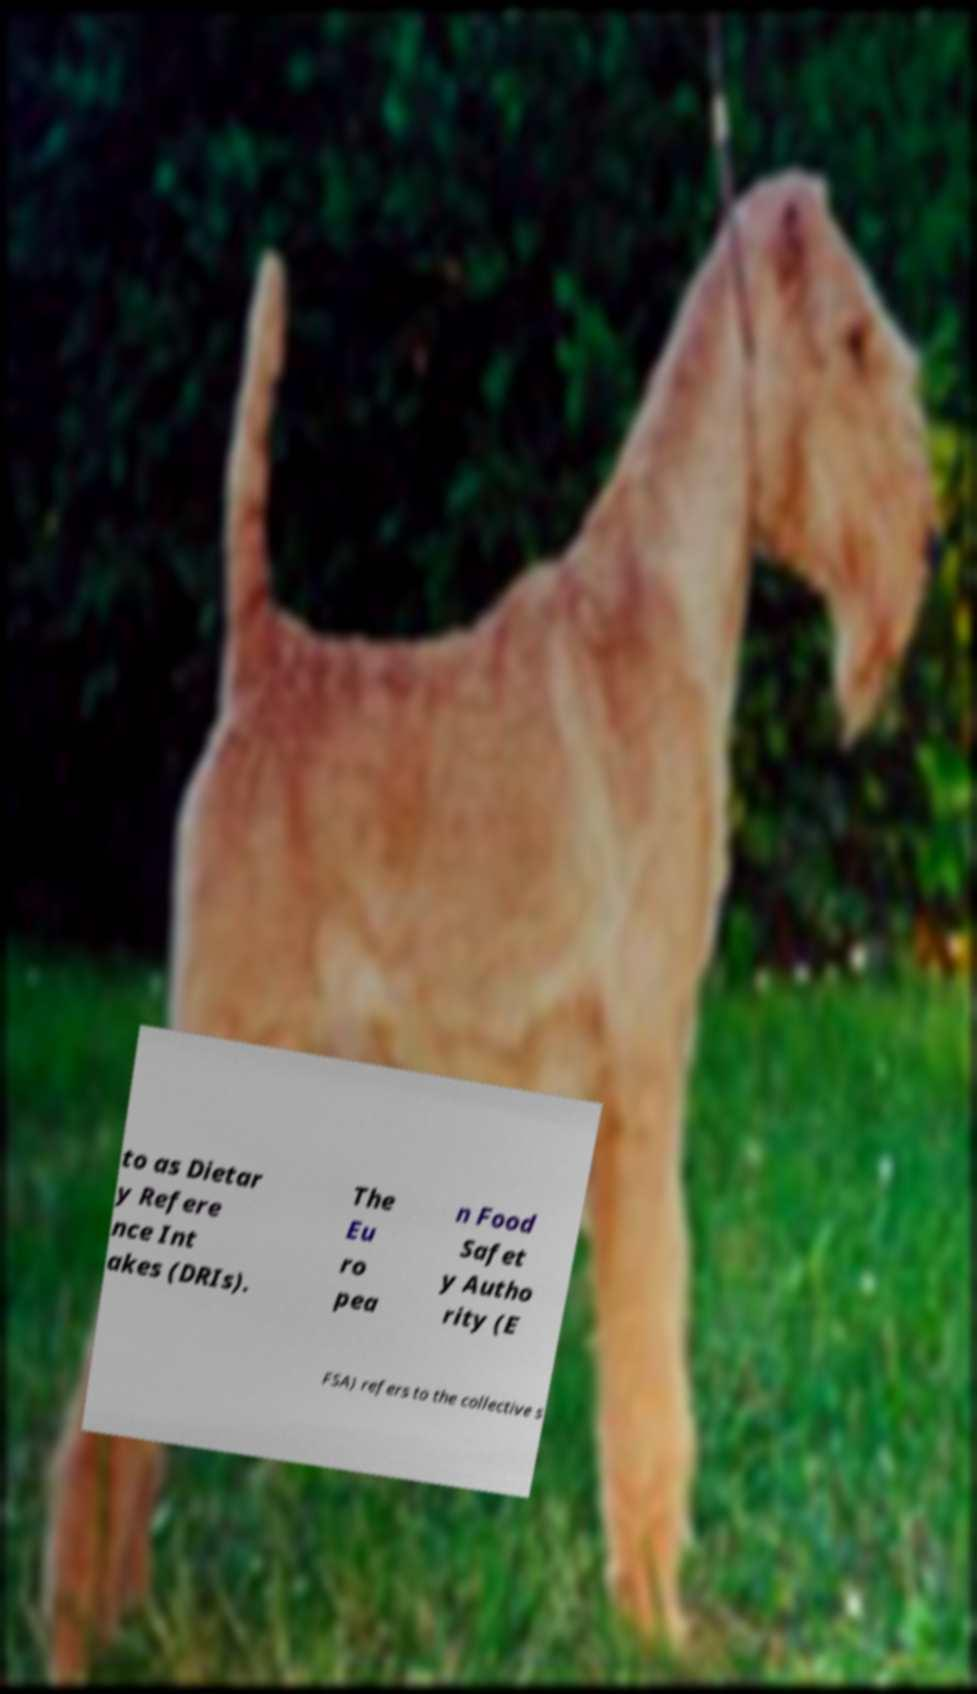Could you assist in decoding the text presented in this image and type it out clearly? to as Dietar y Refere nce Int akes (DRIs). The Eu ro pea n Food Safet y Autho rity (E FSA) refers to the collective s 